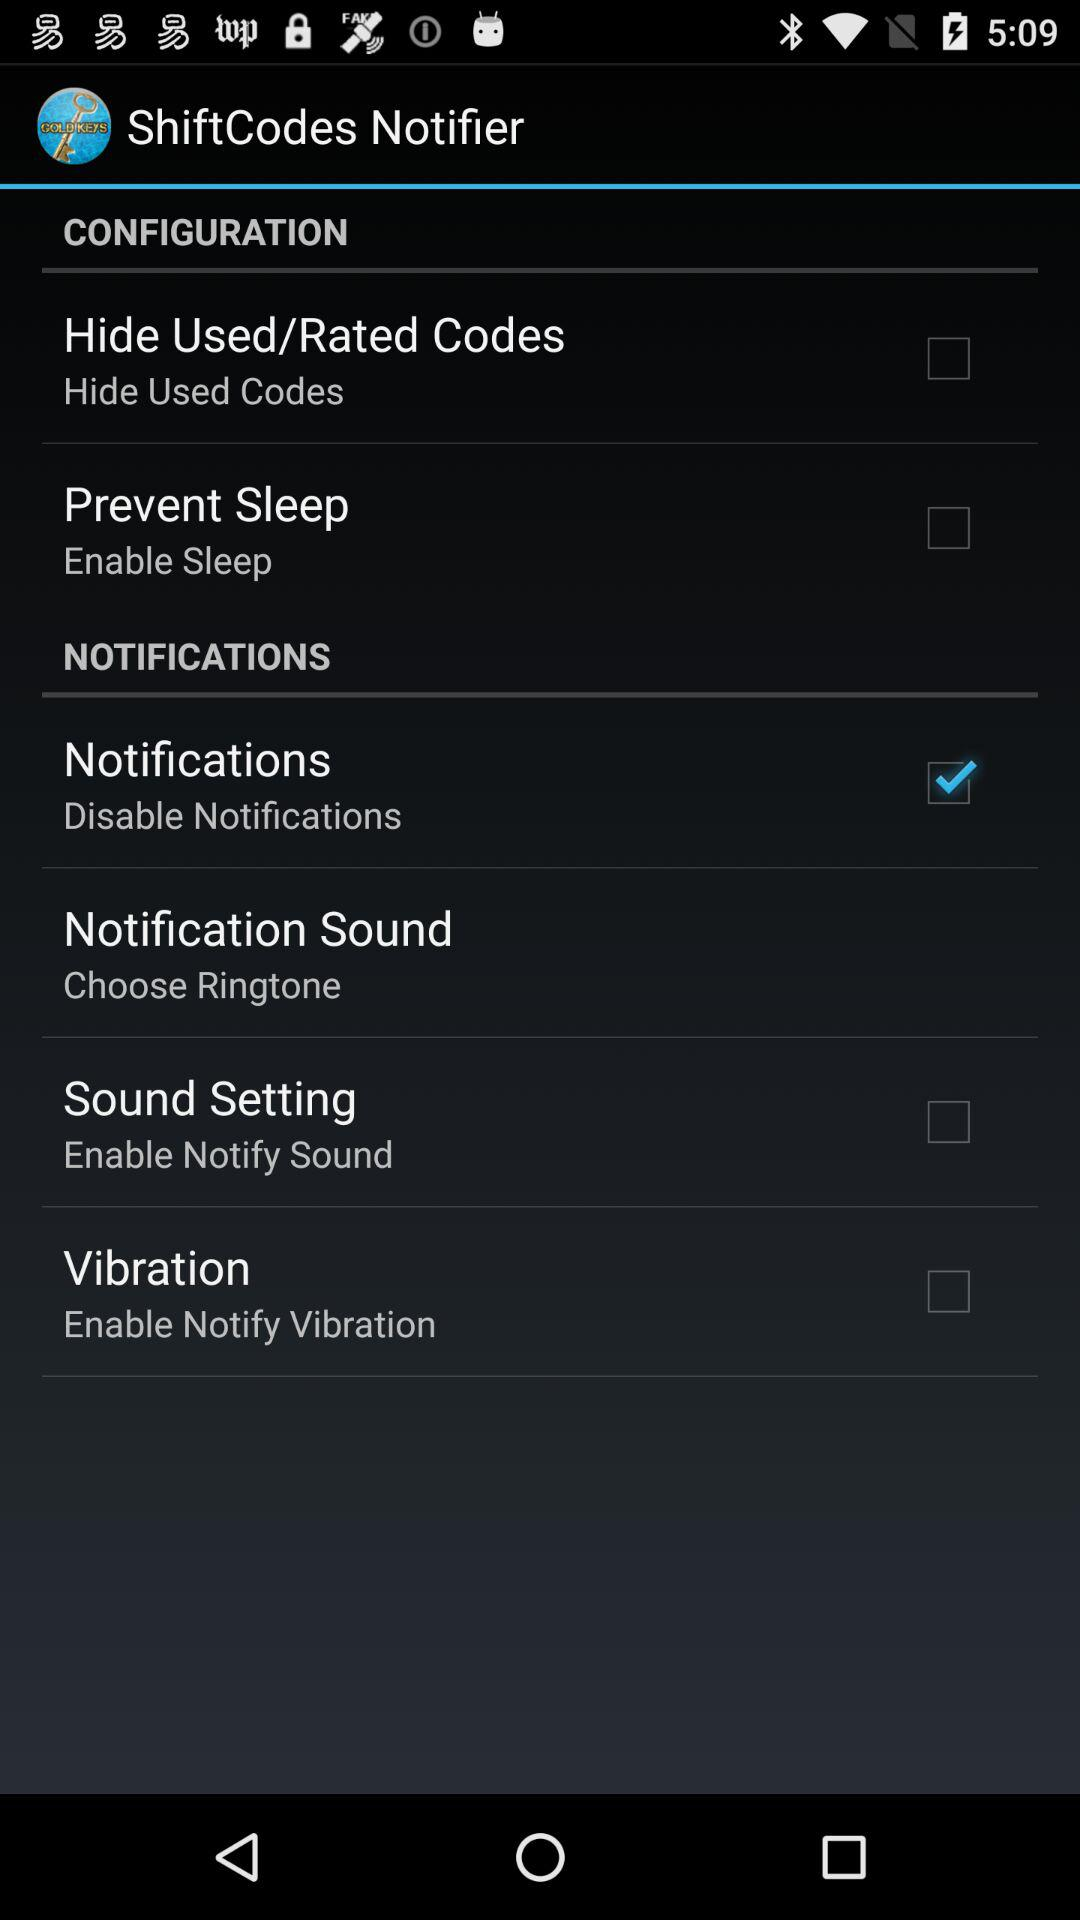How many items are in the Notification section?
Answer the question using a single word or phrase. 4 